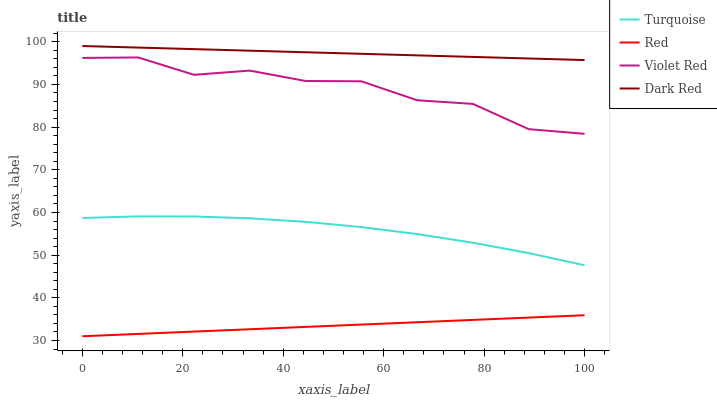Does Red have the minimum area under the curve?
Answer yes or no. Yes. Does Dark Red have the maximum area under the curve?
Answer yes or no. Yes. Does Turquoise have the minimum area under the curve?
Answer yes or no. No. Does Turquoise have the maximum area under the curve?
Answer yes or no. No. Is Dark Red the smoothest?
Answer yes or no. Yes. Is Violet Red the roughest?
Answer yes or no. Yes. Is Turquoise the smoothest?
Answer yes or no. No. Is Turquoise the roughest?
Answer yes or no. No. Does Red have the lowest value?
Answer yes or no. Yes. Does Turquoise have the lowest value?
Answer yes or no. No. Does Dark Red have the highest value?
Answer yes or no. Yes. Does Turquoise have the highest value?
Answer yes or no. No. Is Turquoise less than Dark Red?
Answer yes or no. Yes. Is Turquoise greater than Red?
Answer yes or no. Yes. Does Turquoise intersect Dark Red?
Answer yes or no. No. 